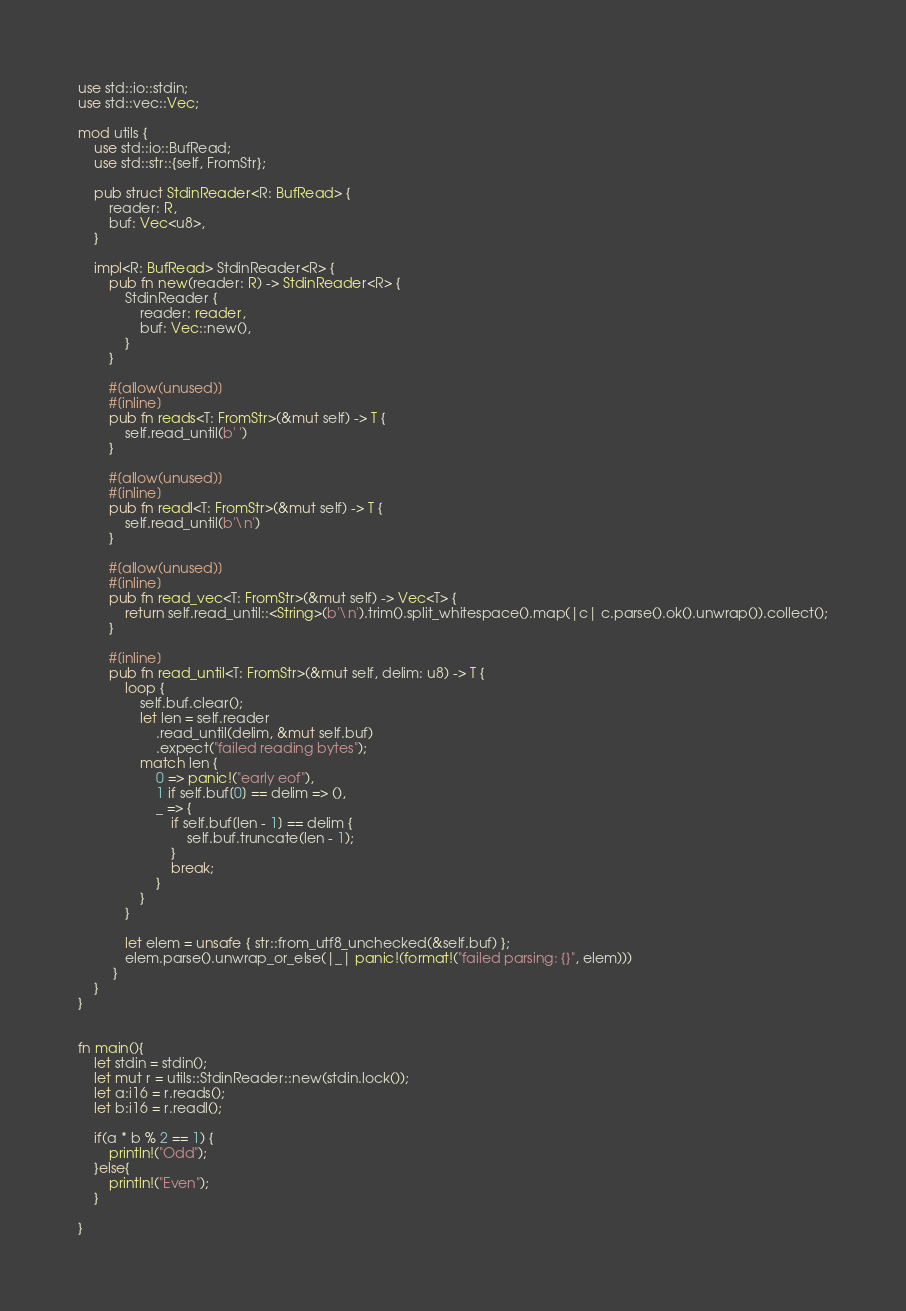Convert code to text. <code><loc_0><loc_0><loc_500><loc_500><_Rust_>use std::io::stdin;
use std::vec::Vec;

mod utils {
    use std::io::BufRead;
    use std::str::{self, FromStr};

    pub struct StdinReader<R: BufRead> {
        reader: R,
        buf: Vec<u8>,
    }

    impl<R: BufRead> StdinReader<R> {
        pub fn new(reader: R) -> StdinReader<R> {
            StdinReader {
                reader: reader,
                buf: Vec::new(),
            }
        }

        #[allow(unused)]
        #[inline]
        pub fn reads<T: FromStr>(&mut self) -> T {
            self.read_until(b' ')
        }

        #[allow(unused)]
        #[inline]
        pub fn readl<T: FromStr>(&mut self) -> T {
            self.read_until(b'\n')
        }

        #[allow(unused)]
        #[inline]
        pub fn read_vec<T: FromStr>(&mut self) -> Vec<T> {
            return self.read_until::<String>(b'\n').trim().split_whitespace().map(|c| c.parse().ok().unwrap()).collect();
        }

        #[inline]
        pub fn read_until<T: FromStr>(&mut self, delim: u8) -> T {
            loop {
                self.buf.clear();
                let len = self.reader
                    .read_until(delim, &mut self.buf)
                    .expect("failed reading bytes");
                match len {
                    0 => panic!("early eof"),
                    1 if self.buf[0] == delim => (),
                    _ => {
                        if self.buf[len - 1] == delim {
                            self.buf.truncate(len - 1);
                        }
                        break;
                    }
                }
            }

            let elem = unsafe { str::from_utf8_unchecked(&self.buf) };
            elem.parse().unwrap_or_else(|_| panic!(format!("failed parsing: {}", elem)))
         }
    }
}


fn main(){
    let stdin = stdin();
    let mut r = utils::StdinReader::new(stdin.lock());
    let a:i16 = r.reads();
    let b:i16 = r.readl();

    if(a * b % 2 == 1) {
        println!("Odd");
    }else{
        println!("Even");
    }

}
</code> 